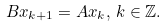<formula> <loc_0><loc_0><loc_500><loc_500>B x _ { k + 1 } = A x _ { k } , \, k \in \mathbb { Z } .</formula> 